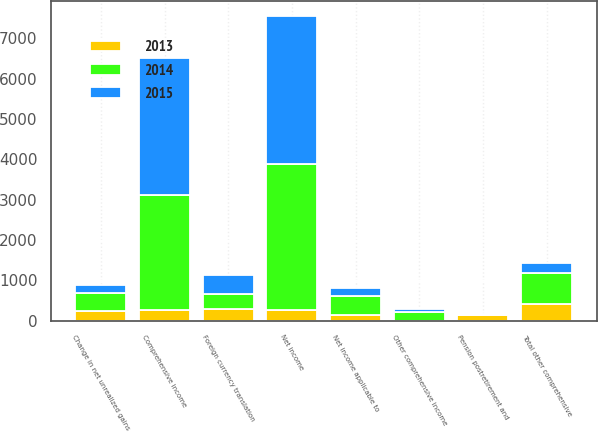Convert chart. <chart><loc_0><loc_0><loc_500><loc_500><stacked_bar_chart><ecel><fcel>Net income<fcel>Foreign currency translation<fcel>Change in net unrealized gains<fcel>Pension postretirement and<fcel>Total other comprehensive<fcel>Comprehensive income<fcel>Net income applicable to<fcel>Other comprehensive income<nl><fcel>2013<fcel>276.5<fcel>304<fcel>246<fcel>138<fcel>412<fcel>276.5<fcel>152<fcel>4<nl><fcel>2015<fcel>3667<fcel>491<fcel>209<fcel>33<fcel>249<fcel>3418<fcel>200<fcel>94<nl><fcel>2014<fcel>3613<fcel>348<fcel>433<fcel>1<fcel>782<fcel>2831<fcel>459<fcel>205<nl></chart> 